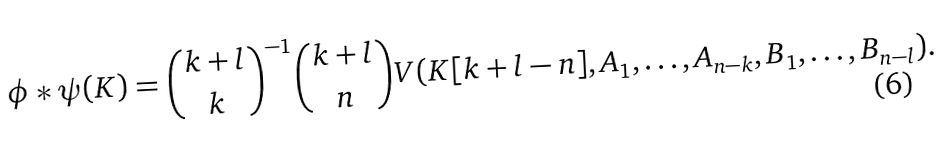<formula> <loc_0><loc_0><loc_500><loc_500>\phi * \psi ( K ) = \binom { k + l } { k } ^ { - 1 } \binom { k + l } { n } V ( K [ k + l - n ] , A _ { 1 } , \dots , A _ { n - k } , B _ { 1 } , \dots , B _ { n - l } ) .</formula> 